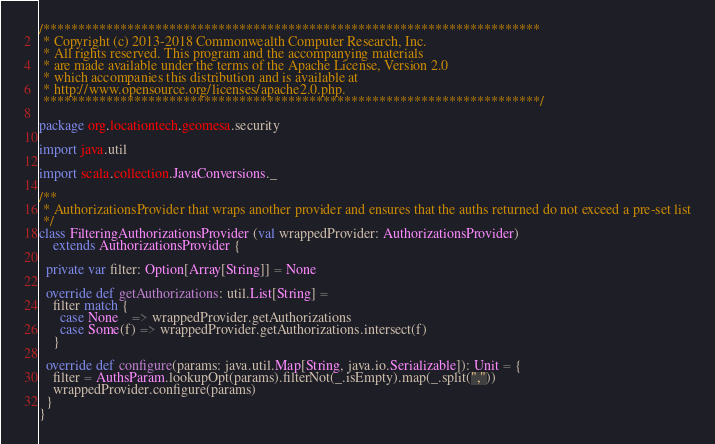Convert code to text. <code><loc_0><loc_0><loc_500><loc_500><_Scala_>/***********************************************************************
 * Copyright (c) 2013-2018 Commonwealth Computer Research, Inc.
 * All rights reserved. This program and the accompanying materials
 * are made available under the terms of the Apache License, Version 2.0
 * which accompanies this distribution and is available at
 * http://www.opensource.org/licenses/apache2.0.php.
 ***********************************************************************/

package org.locationtech.geomesa.security

import java.util

import scala.collection.JavaConversions._

/**
 * AuthorizationsProvider that wraps another provider and ensures that the auths returned do not exceed a pre-set list
 */
class FilteringAuthorizationsProvider (val wrappedProvider: AuthorizationsProvider)
    extends AuthorizationsProvider {

  private var filter: Option[Array[String]] = None

  override def getAuthorizations: util.List[String] =
    filter match {
      case None    => wrappedProvider.getAuthorizations
      case Some(f) => wrappedProvider.getAuthorizations.intersect(f)
    }

  override def configure(params: java.util.Map[String, java.io.Serializable]): Unit = {
    filter = AuthsParam.lookupOpt(params).filterNot(_.isEmpty).map(_.split(","))
    wrappedProvider.configure(params)
  }
}
</code> 